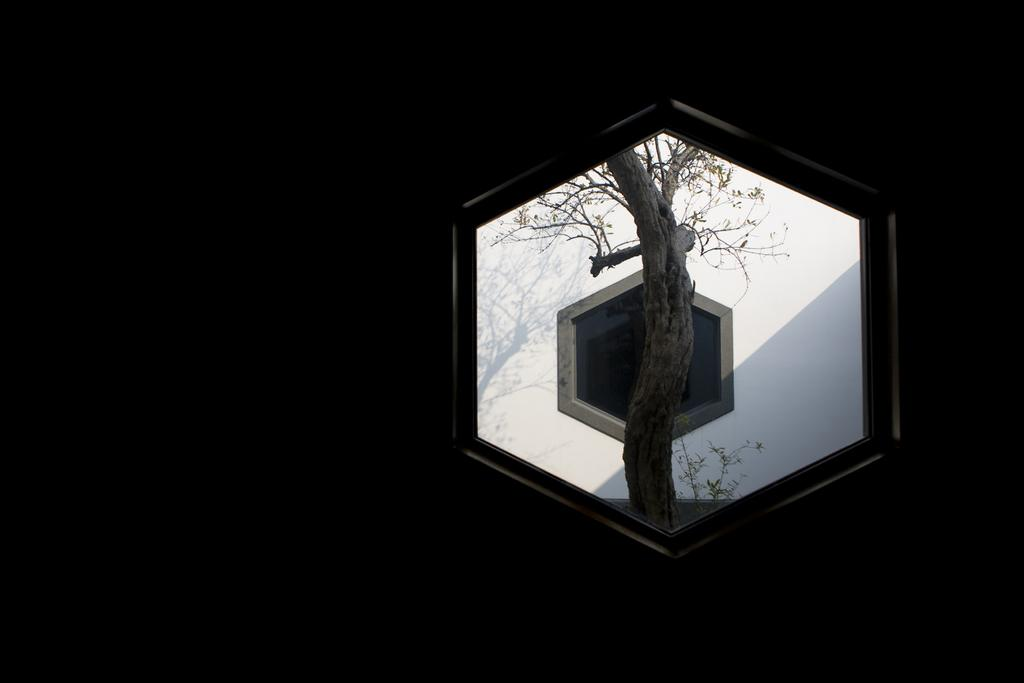What can be seen through the window in the image? There is another window visible through the first window, and a tree can be seen through both windows. How many windows are visible in the image? There are two windows visible in the image. What type of shoes are hanging from the tree in the image? There are no shoes present in the image; it only features windows and a tree. 